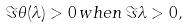<formula> <loc_0><loc_0><loc_500><loc_500>\Im \theta ( \lambda ) > 0 \, w h e n \, \Im \lambda > 0 ,</formula> 